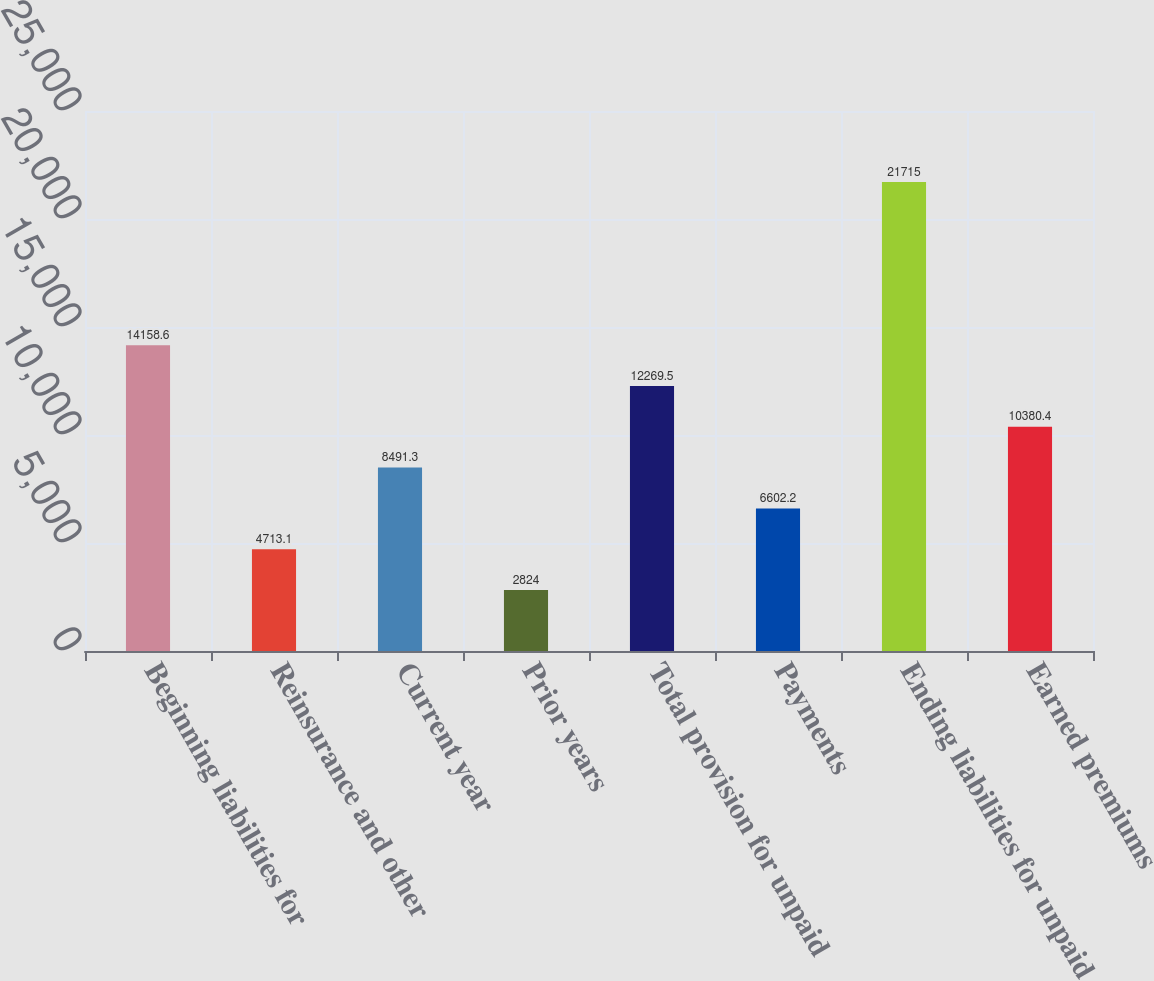<chart> <loc_0><loc_0><loc_500><loc_500><bar_chart><fcel>Beginning liabilities for<fcel>Reinsurance and other<fcel>Current year<fcel>Prior years<fcel>Total provision for unpaid<fcel>Payments<fcel>Ending liabilities for unpaid<fcel>Earned premiums<nl><fcel>14158.6<fcel>4713.1<fcel>8491.3<fcel>2824<fcel>12269.5<fcel>6602.2<fcel>21715<fcel>10380.4<nl></chart> 